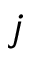Convert formula to latex. <formula><loc_0><loc_0><loc_500><loc_500>j</formula> 